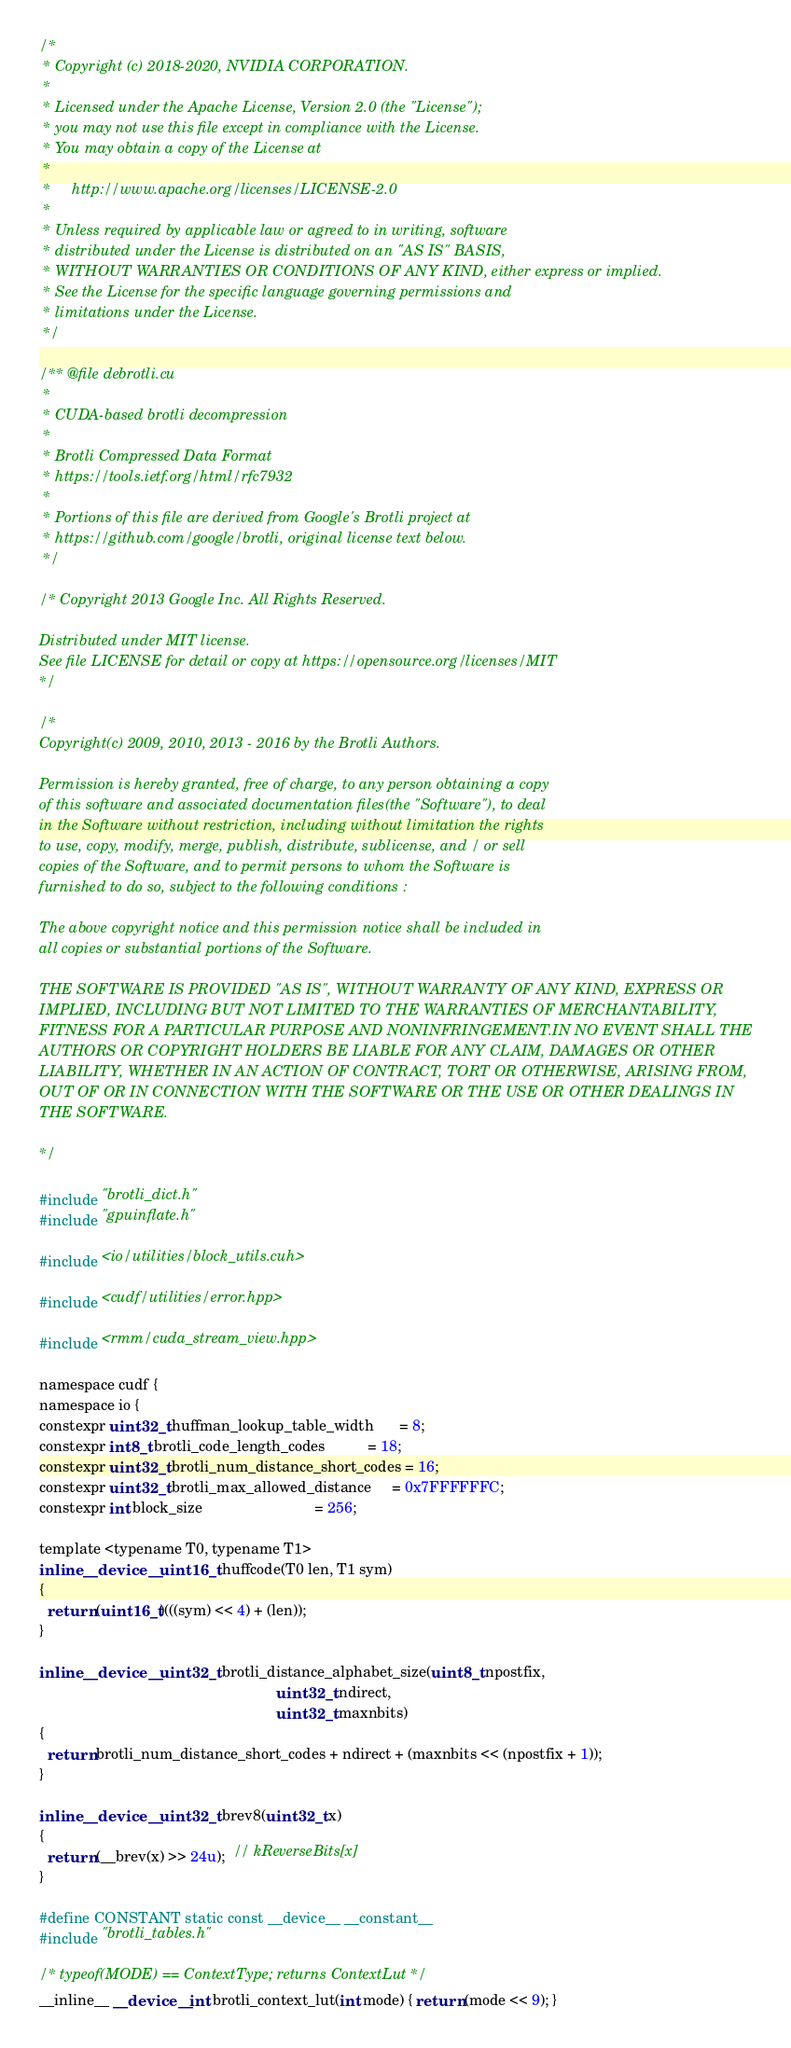<code> <loc_0><loc_0><loc_500><loc_500><_Cuda_>/*
 * Copyright (c) 2018-2020, NVIDIA CORPORATION.
 *
 * Licensed under the Apache License, Version 2.0 (the "License");
 * you may not use this file except in compliance with the License.
 * You may obtain a copy of the License at
 *
 *     http://www.apache.org/licenses/LICENSE-2.0
 *
 * Unless required by applicable law or agreed to in writing, software
 * distributed under the License is distributed on an "AS IS" BASIS,
 * WITHOUT WARRANTIES OR CONDITIONS OF ANY KIND, either express or implied.
 * See the License for the specific language governing permissions and
 * limitations under the License.
 */

/** @file debrotli.cu
 *
 * CUDA-based brotli decompression
 *
 * Brotli Compressed Data Format
 * https://tools.ietf.org/html/rfc7932
 *
 * Portions of this file are derived from Google's Brotli project at
 * https://github.com/google/brotli, original license text below.
 */

/* Copyright 2013 Google Inc. All Rights Reserved.

Distributed under MIT license.
See file LICENSE for detail or copy at https://opensource.org/licenses/MIT
*/

/*
Copyright(c) 2009, 2010, 2013 - 2016 by the Brotli Authors.

Permission is hereby granted, free of charge, to any person obtaining a copy
of this software and associated documentation files(the "Software"), to deal
in the Software without restriction, including without limitation the rights
to use, copy, modify, merge, publish, distribute, sublicense, and / or sell
copies of the Software, and to permit persons to whom the Software is
furnished to do so, subject to the following conditions :

The above copyright notice and this permission notice shall be included in
all copies or substantial portions of the Software.

THE SOFTWARE IS PROVIDED "AS IS", WITHOUT WARRANTY OF ANY KIND, EXPRESS OR
IMPLIED, INCLUDING BUT NOT LIMITED TO THE WARRANTIES OF MERCHANTABILITY,
FITNESS FOR A PARTICULAR PURPOSE AND NONINFRINGEMENT.IN NO EVENT SHALL THE
AUTHORS OR COPYRIGHT HOLDERS BE LIABLE FOR ANY CLAIM, DAMAGES OR OTHER
LIABILITY, WHETHER IN AN ACTION OF CONTRACT, TORT OR OTHERWISE, ARISING FROM,
OUT OF OR IN CONNECTION WITH THE SOFTWARE OR THE USE OR OTHER DEALINGS IN
THE SOFTWARE.

*/

#include "brotli_dict.h"
#include "gpuinflate.h"

#include <io/utilities/block_utils.cuh>

#include <cudf/utilities/error.hpp>

#include <rmm/cuda_stream_view.hpp>

namespace cudf {
namespace io {
constexpr uint32_t huffman_lookup_table_width      = 8;
constexpr int8_t brotli_code_length_codes          = 18;
constexpr uint32_t brotli_num_distance_short_codes = 16;
constexpr uint32_t brotli_max_allowed_distance     = 0x7FFFFFFC;
constexpr int block_size                           = 256;

template <typename T0, typename T1>
inline __device__ uint16_t huffcode(T0 len, T1 sym)
{
  return (uint16_t)(((sym) << 4) + (len));
}

inline __device__ uint32_t brotli_distance_alphabet_size(uint8_t npostfix,
                                                         uint32_t ndirect,
                                                         uint32_t maxnbits)
{
  return brotli_num_distance_short_codes + ndirect + (maxnbits << (npostfix + 1));
}

inline __device__ uint32_t brev8(uint32_t x)
{
  return (__brev(x) >> 24u);  // kReverseBits[x]
}

#define CONSTANT static const __device__ __constant__
#include "brotli_tables.h"

/* typeof(MODE) == ContextType; returns ContextLut */
__inline__ __device__ int brotli_context_lut(int mode) { return (mode << 9); }
</code> 